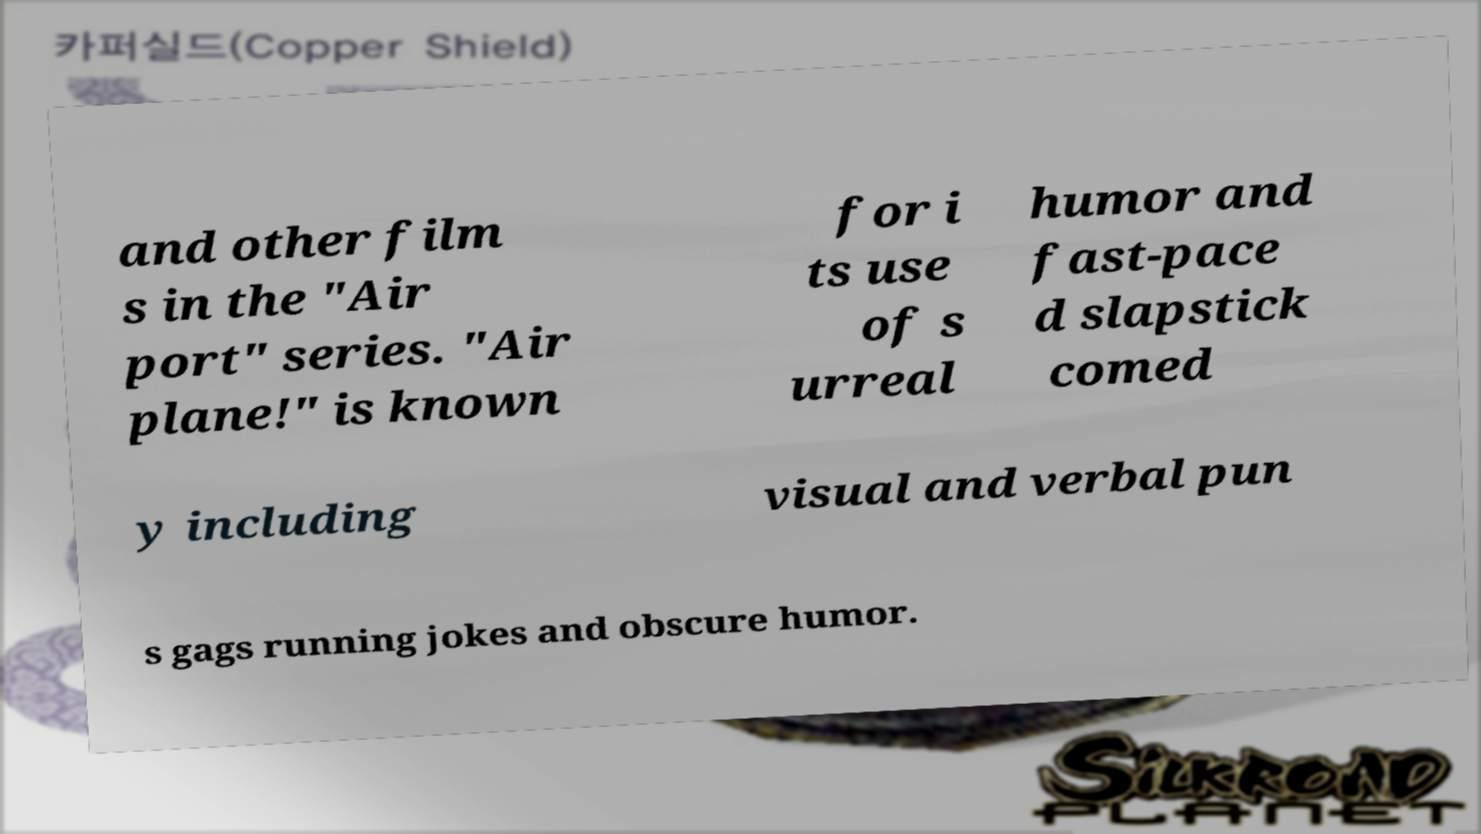What messages or text are displayed in this image? I need them in a readable, typed format. and other film s in the "Air port" series. "Air plane!" is known for i ts use of s urreal humor and fast-pace d slapstick comed y including visual and verbal pun s gags running jokes and obscure humor. 